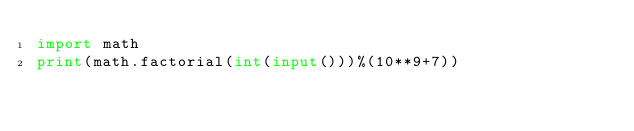<code> <loc_0><loc_0><loc_500><loc_500><_Python_>import math
print(math.factorial(int(input()))%(10**9+7))</code> 